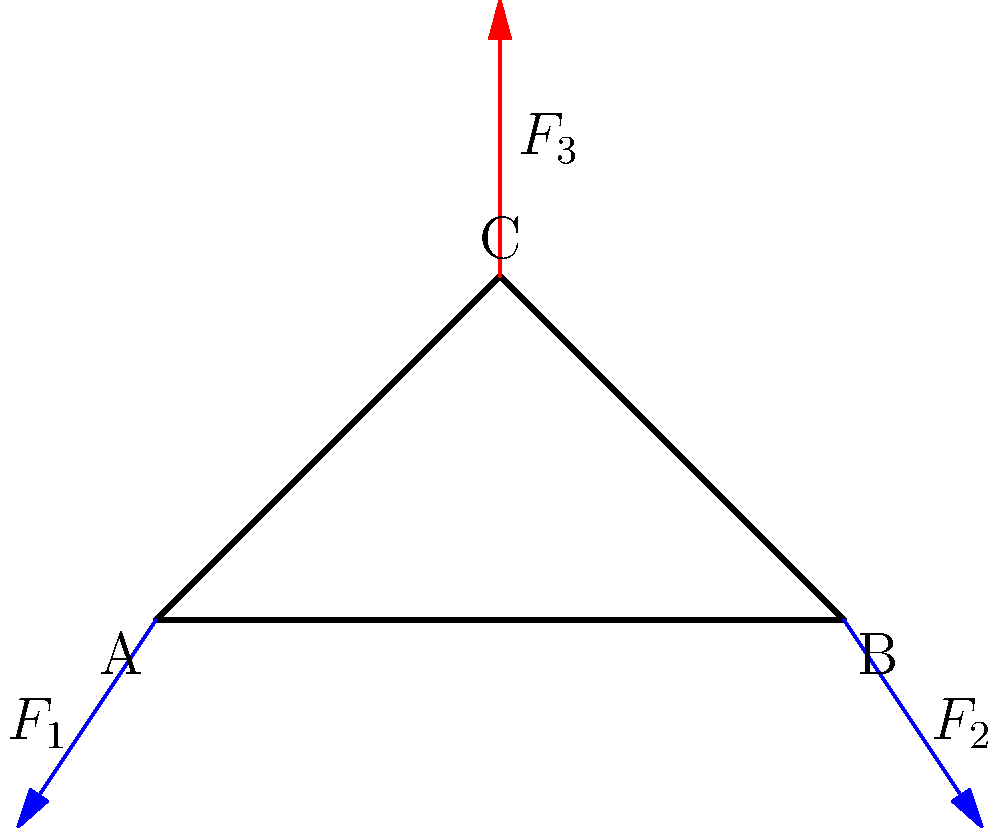In the truss bridge structure shown above, forces $F_1$, $F_2$, and $F_3$ are acting on the joints A, B, and C respectively. If $F_1 = 50$ kN at 236.3°, $F_2 = 50$ kN at 303.7°, and the structure is in equilibrium, what is the magnitude and direction of $F_3$? To solve this problem, we'll use the principle of equilibrium, which states that the sum of all forces acting on a structure at rest must equal zero. We'll follow these steps:

1) Convert the given forces to their x and y components:
   $F_{1x} = 50 \cos(236.3°) = -30$ kN
   $F_{1y} = 50 \sin(236.3°) = -40$ kN
   $F_{2x} = 50 \cos(303.7°) = 30$ kN
   $F_{2y} = 50 \sin(303.7°) = -40$ kN

2) Apply the equilibrium equations:
   $\sum F_x = 0$: $F_{1x} + F_{2x} + F_{3x} = 0$
   $\sum F_y = 0$: $F_{1y} + F_{2y} + F_{3y} = 0$

3) Substitute the known values:
   $-30 + 30 + F_{3x} = 0$
   $-40 - 40 + F_{3y} = 0$

4) Solve for $F_{3x}$ and $F_{3y}$:
   $F_{3x} = 0$ kN
   $F_{3y} = 80$ kN

5) Calculate the magnitude of $F_3$ using the Pythagorean theorem:
   $|F_3| = \sqrt{F_{3x}^2 + F_{3y}^2} = \sqrt{0^2 + 80^2} = 80$ kN

6) Calculate the direction of $F_3$ using trigonometry:
   $\theta = \tan^{-1}(\frac{F_{3y}}{F_{3x}}) = \tan^{-1}(\frac{80}{0}) = 90°$

Therefore, $F_3$ has a magnitude of 80 kN and acts vertically upward at 90°.
Answer: 80 kN at 90° 